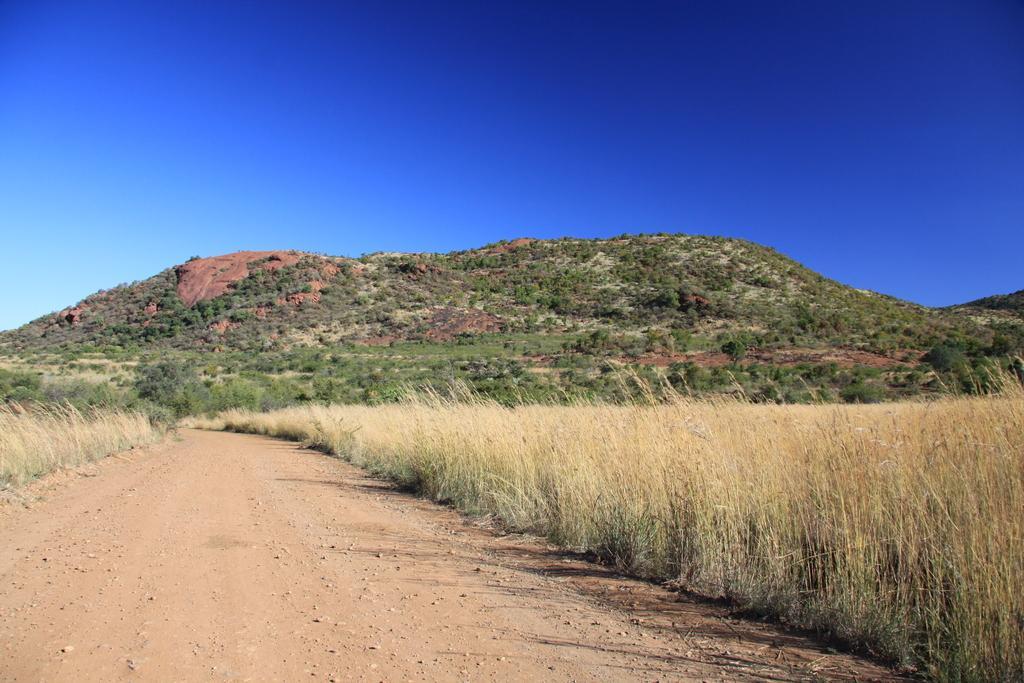Can you describe this image briefly? In this image, I can see the dried grass. This looks like a hill with the trees. I think this is the pathway. Here is the sky. 